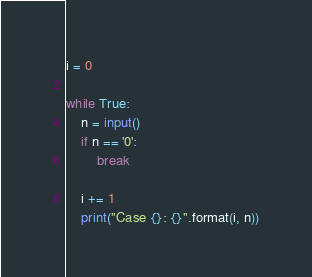<code> <loc_0><loc_0><loc_500><loc_500><_Python_>i = 0

while True:
    n = input()
    if n == '0':
        break

    i += 1
    print("Case {}: {}".format(i, n))

</code> 